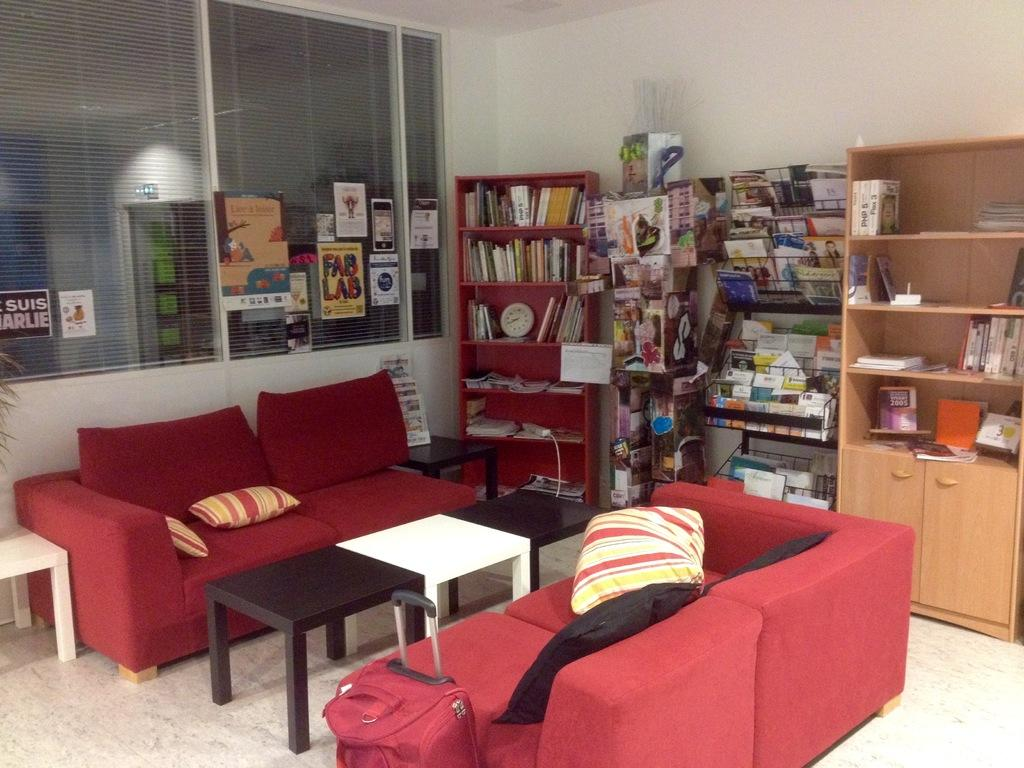What type of furniture is present in the image? There are sofas in the image. What is placed on the sofas? There are pillows on the sofas. What other types of furniture can be seen in the image? There are tables in the image. What is on the walls in the image? There are shelves in the image. What items are on the shelves? There are books and other things arranged on the shelves. What type of knife is used to cut the oatmeal in the image? There is no knife or oatmeal present in the image. What is the profit margin of the items on the shelves in the image? There is no information about the profit margin of the items on the shelves in the image. 